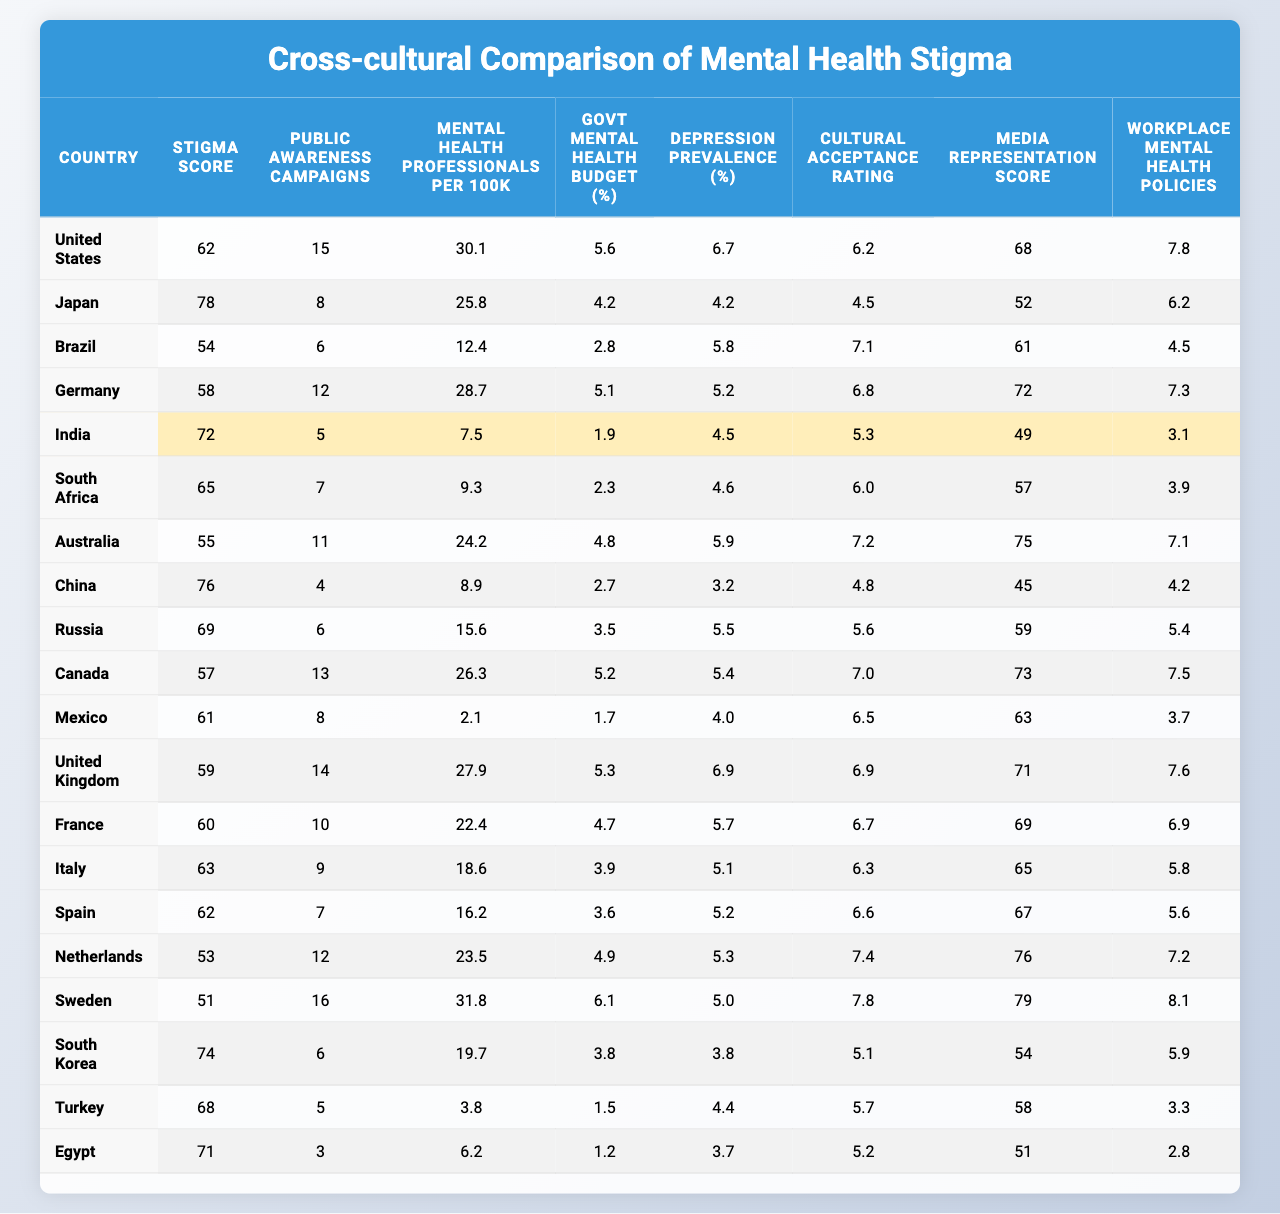What is the stigma score for Germany? The stigma score for Germany can be found in the table under the "Stigma Score" column next to Germany, which shows a value of 58.
Answer: 58 Which country has the highest number of mental health professionals per 100k population? By examining the "Mental Health Professionals per 100k" column, the highest value is 31.8, which corresponds to Sweden.
Answer: Sweden What is the average stigma score of the countries listed? First, sum all stigma scores: (62 + 78 + 54 + 58 + 72 + 65 + 55 + 76 + 69 + 57 + 61 + 59 + 60 + 63 + 62 + 53 + 51 + 74 + 68 + 71) = 1315. Then divide by the number of countries (20): 1315 / 20 = 65.75.
Answer: 65.75 How many public awareness campaigns does South Africa have? The number of public awareness campaigns for South Africa is provided under the corresponding column for South Africa, which shows a value of 7.
Answer: 7 Is the mental health budget percentage in Mexico higher than that in Canada? The table shows Mexico with a budget of 1.7% and Canada with 5.2%. Since 1.7% is less than 5.2%, the statement is false.
Answer: No Which country has the lowest cultural acceptance rating? By looking at the "Cultural Acceptance Rating" column, Egypt has the lowest rating of 5.1.
Answer: Egypt What is the difference in stigma scores between the United States and Japan? The stigma score for the United States is 62, while for Japan it is 78. The difference is calculated as 78 - 62 = 16.
Answer: 16 Which country has the highest workplace mental health policies score and what is the score? The column for "Workplace Mental Health Policies" shows that Sweden has the highest score of 8.1.
Answer: Sweden, 8.1 Is there a correlation between the number of public awareness campaigns and the stigma score? To determine this, one can observe that countries with higher scores like Japan (8 campaigns, score 78) and Brazil (6 campaigns, score 54) show that there is no clear correlation as increase in campaigns doesn't consistently lower stigma scores.
Answer: No clear correlation What percentage of the government budget is allocated to mental health in India? The percentage for India can be found in the "Govt Mental Health Budget (%)" column next to India, which indicates a value of 1.9%.
Answer: 1.9% 